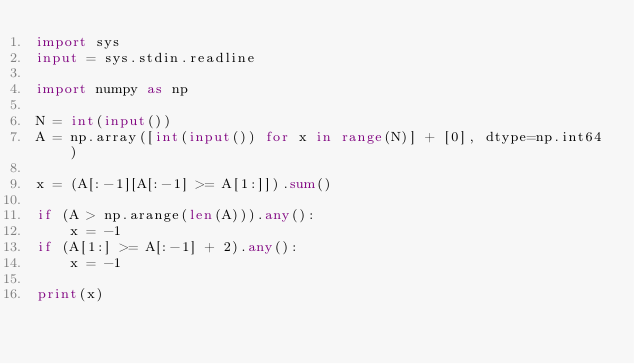Convert code to text. <code><loc_0><loc_0><loc_500><loc_500><_Python_>import sys
input = sys.stdin.readline

import numpy as np

N = int(input())
A = np.array([int(input()) for x in range(N)] + [0], dtype=np.int64)

x = (A[:-1][A[:-1] >= A[1:]]).sum()

if (A > np.arange(len(A))).any():
    x = -1
if (A[1:] >= A[:-1] + 2).any():
    x = -1

print(x)</code> 